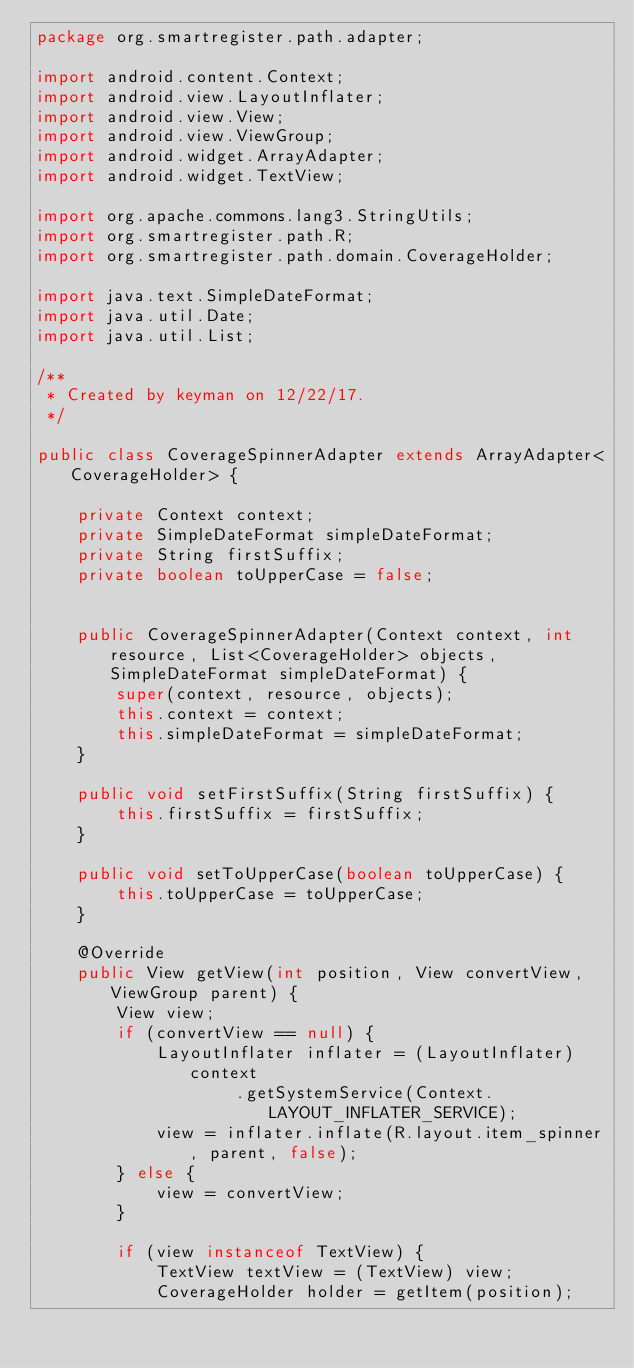<code> <loc_0><loc_0><loc_500><loc_500><_Java_>package org.smartregister.path.adapter;

import android.content.Context;
import android.view.LayoutInflater;
import android.view.View;
import android.view.ViewGroup;
import android.widget.ArrayAdapter;
import android.widget.TextView;

import org.apache.commons.lang3.StringUtils;
import org.smartregister.path.R;
import org.smartregister.path.domain.CoverageHolder;

import java.text.SimpleDateFormat;
import java.util.Date;
import java.util.List;

/**
 * Created by keyman on 12/22/17.
 */

public class CoverageSpinnerAdapter extends ArrayAdapter<CoverageHolder> {

    private Context context;
    private SimpleDateFormat simpleDateFormat;
    private String firstSuffix;
    private boolean toUpperCase = false;


    public CoverageSpinnerAdapter(Context context, int resource, List<CoverageHolder> objects, SimpleDateFormat simpleDateFormat) {
        super(context, resource, objects);
        this.context = context;
        this.simpleDateFormat = simpleDateFormat;
    }

    public void setFirstSuffix(String firstSuffix) {
        this.firstSuffix = firstSuffix;
    }

    public void setToUpperCase(boolean toUpperCase) {
        this.toUpperCase = toUpperCase;
    }

    @Override
    public View getView(int position, View convertView, ViewGroup parent) {
        View view;
        if (convertView == null) {
            LayoutInflater inflater = (LayoutInflater) context
                    .getSystemService(Context.LAYOUT_INFLATER_SERVICE);
            view = inflater.inflate(R.layout.item_spinner, parent, false);
        } else {
            view = convertView;
        }

        if (view instanceof TextView) {
            TextView textView = (TextView) view;
            CoverageHolder holder = getItem(position);</code> 